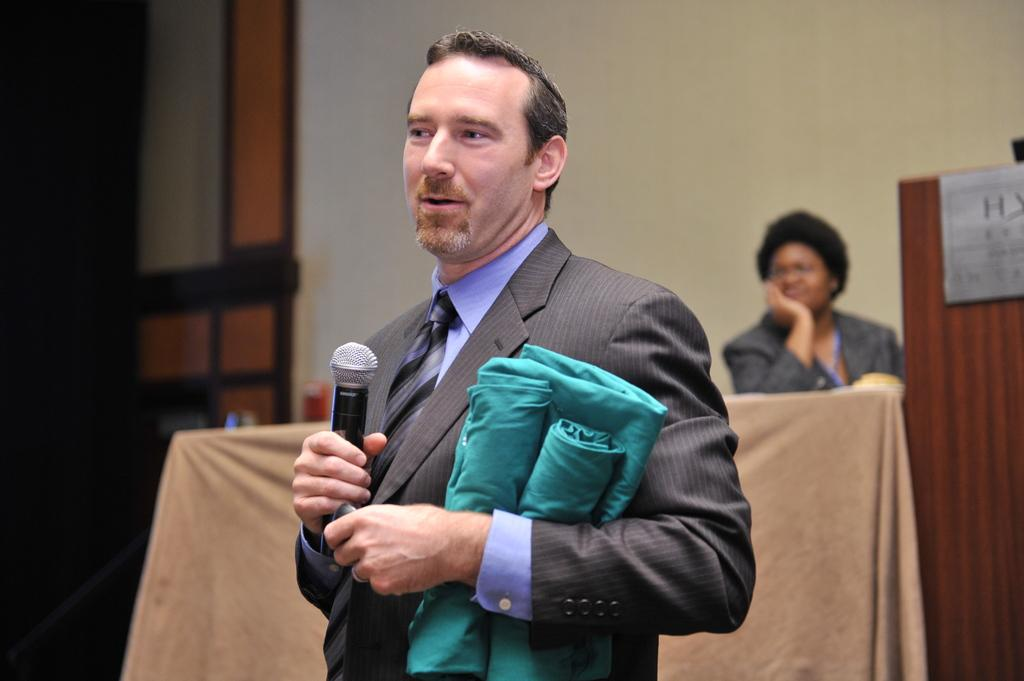What is the main subject of the image? The main subject of the image is a guy. What is the guy doing in the image? The guy is talking in the image. What is the guy holding in his hand? The guy is holding a mic in his hand. What else is the guy holding in his other hand? The guy is holding a blue color cloth in his other hand. Can you describe the lady in the background of the image? The lady is sitting on a brown table in the background of the image. How many bananas can be seen on the scale in the image? There is no scale or bananas present in the image. What color are the lady's eyes in the image? The lady's eyes are not visible in the image, so we cannot determine their color. 